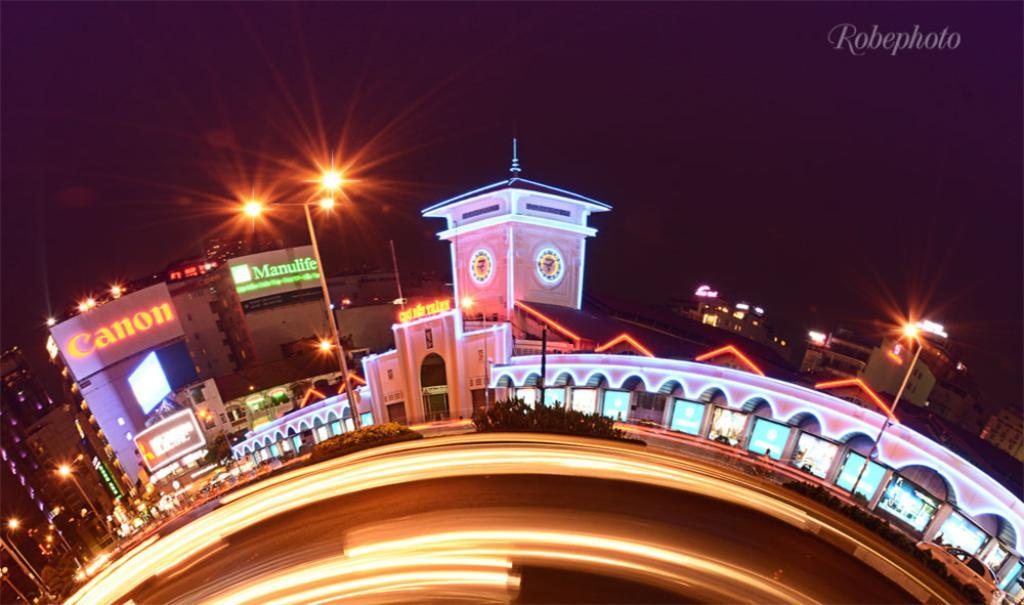Provide a one-sentence caption for the provided image. A view of the city with Canon and Manulife buildings at the background. 